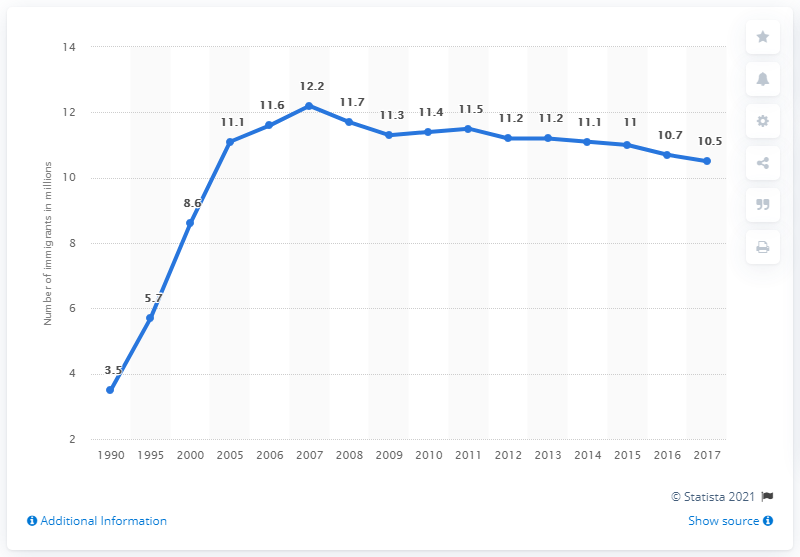Point out several critical features in this image. In 1990, it is estimated that approximately 3.5 million unauthorized immigrants resided in the United States. In 2017, it is estimated that approximately 10.5 million unauthorized immigrants resided in the United States. 